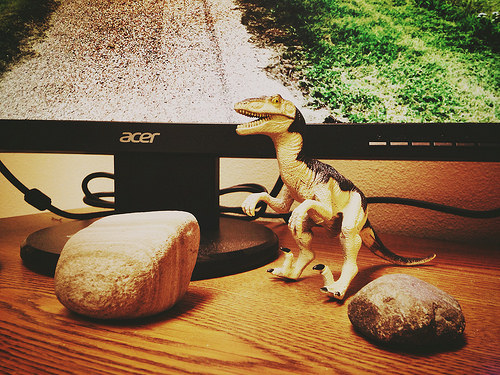<image>
Is there a dinosaur on the grass? No. The dinosaur is not positioned on the grass. They may be near each other, but the dinosaur is not supported by or resting on top of the grass. Is the dinosaur to the right of the large rock? Yes. From this viewpoint, the dinosaur is positioned to the right side relative to the large rock. 